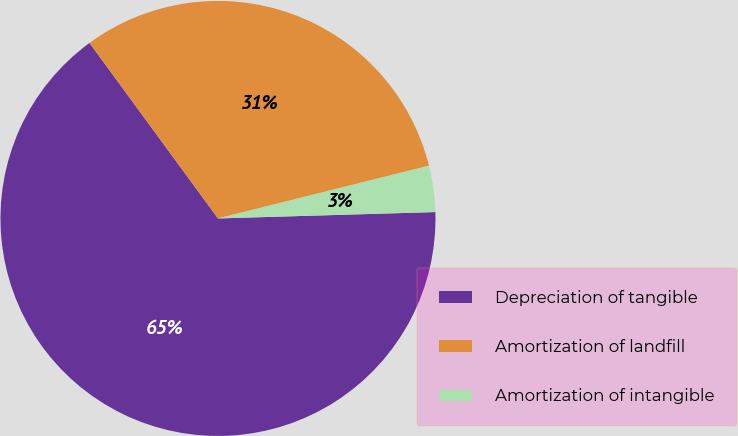Convert chart to OTSL. <chart><loc_0><loc_0><loc_500><loc_500><pie_chart><fcel>Depreciation of tangible<fcel>Amortization of landfill<fcel>Amortization of intangible<nl><fcel>65.41%<fcel>31.16%<fcel>3.43%<nl></chart> 